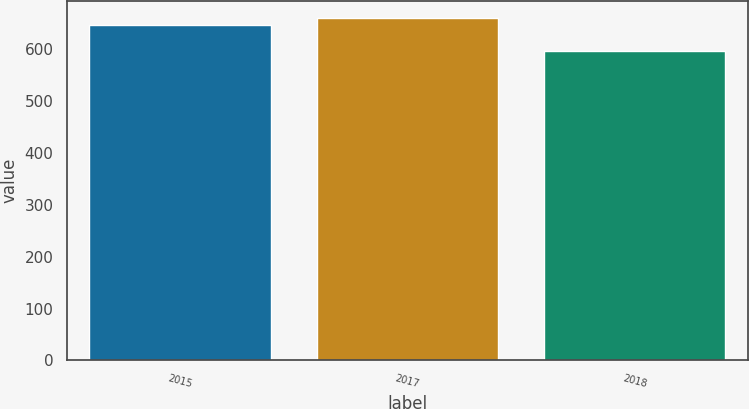Convert chart. <chart><loc_0><loc_0><loc_500><loc_500><bar_chart><fcel>2015<fcel>2017<fcel>2018<nl><fcel>647<fcel>660<fcel>597<nl></chart> 